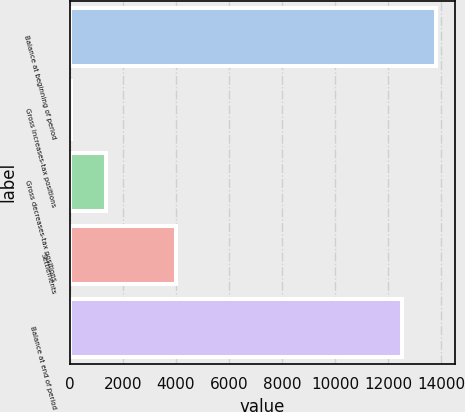Convert chart to OTSL. <chart><loc_0><loc_0><loc_500><loc_500><bar_chart><fcel>Balance at beginning of period<fcel>Gross increases-tax positions<fcel>Gross decreases-tax positions<fcel>Settlements<fcel>Balance at end of period<nl><fcel>13812.1<fcel>64<fcel>1371.1<fcel>3985.3<fcel>12505<nl></chart> 